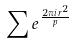<formula> <loc_0><loc_0><loc_500><loc_500>\sum e ^ { \frac { 2 \pi i r ^ { 2 } } { p } }</formula> 